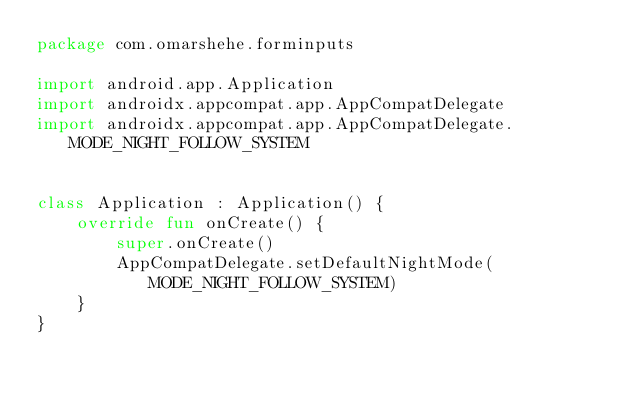<code> <loc_0><loc_0><loc_500><loc_500><_Kotlin_>package com.omarshehe.forminputs

import android.app.Application
import androidx.appcompat.app.AppCompatDelegate
import androidx.appcompat.app.AppCompatDelegate.MODE_NIGHT_FOLLOW_SYSTEM


class Application : Application() {
    override fun onCreate() {
        super.onCreate()
        AppCompatDelegate.setDefaultNightMode(MODE_NIGHT_FOLLOW_SYSTEM)
    }
}</code> 